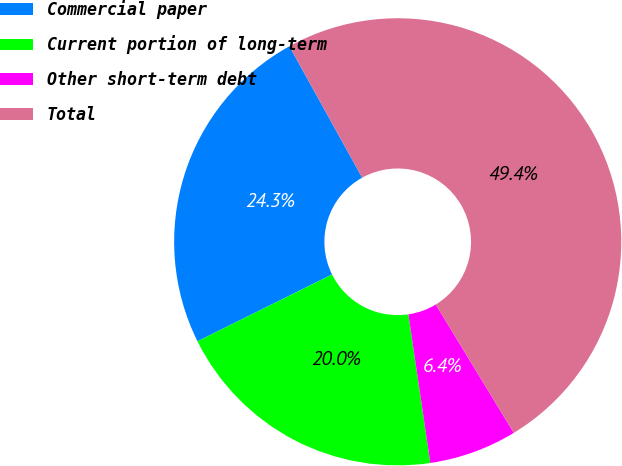Convert chart to OTSL. <chart><loc_0><loc_0><loc_500><loc_500><pie_chart><fcel>Commercial paper<fcel>Current portion of long-term<fcel>Other short-term debt<fcel>Total<nl><fcel>24.29%<fcel>19.99%<fcel>6.36%<fcel>49.36%<nl></chart> 